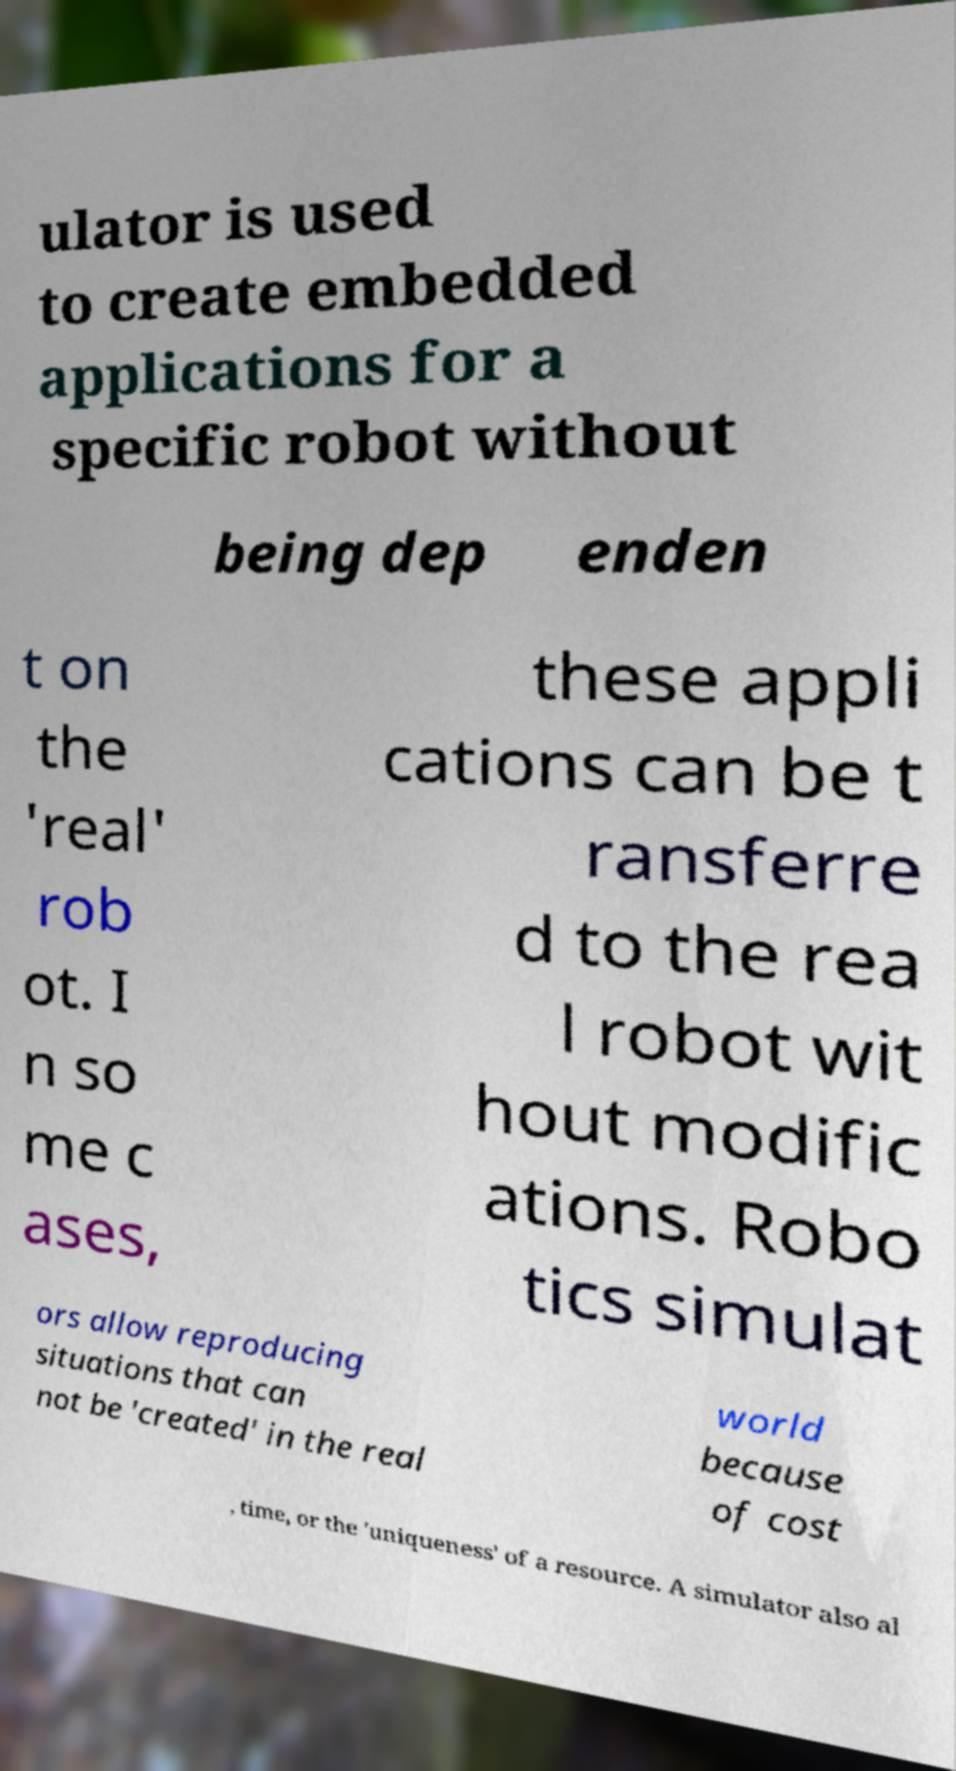Can you accurately transcribe the text from the provided image for me? ulator is used to create embedded applications for a specific robot without being dep enden t on the 'real' rob ot. I n so me c ases, these appli cations can be t ransferre d to the rea l robot wit hout modific ations. Robo tics simulat ors allow reproducing situations that can not be 'created' in the real world because of cost , time, or the 'uniqueness' of a resource. A simulator also al 